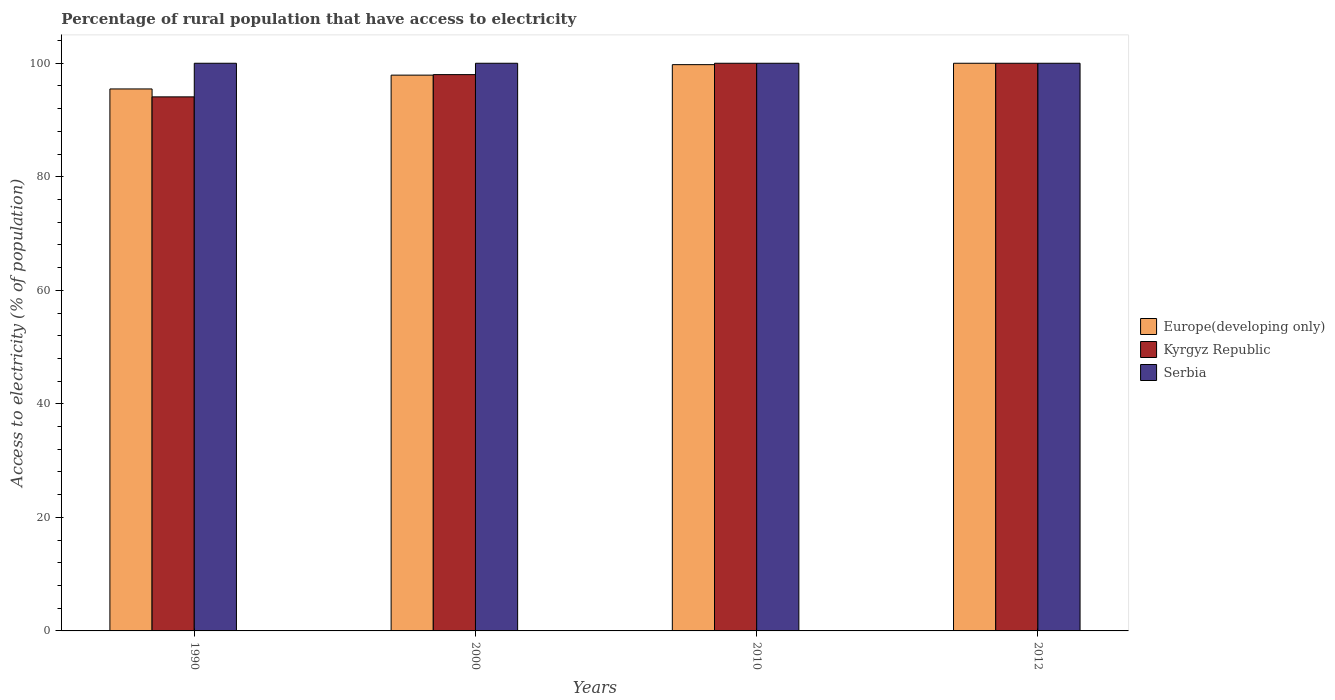How many different coloured bars are there?
Offer a terse response. 3. Are the number of bars on each tick of the X-axis equal?
Offer a terse response. Yes. How many bars are there on the 2nd tick from the left?
Provide a succinct answer. 3. How many bars are there on the 1st tick from the right?
Your response must be concise. 3. What is the label of the 1st group of bars from the left?
Ensure brevity in your answer.  1990. In how many cases, is the number of bars for a given year not equal to the number of legend labels?
Provide a short and direct response. 0. What is the percentage of rural population that have access to electricity in Kyrgyz Republic in 2000?
Provide a succinct answer. 98. Across all years, what is the minimum percentage of rural population that have access to electricity in Serbia?
Ensure brevity in your answer.  100. In which year was the percentage of rural population that have access to electricity in Kyrgyz Republic maximum?
Ensure brevity in your answer.  2010. What is the total percentage of rural population that have access to electricity in Serbia in the graph?
Your answer should be very brief. 400. What is the difference between the percentage of rural population that have access to electricity in Kyrgyz Republic in 1990 and that in 2012?
Provide a short and direct response. -5.92. What is the difference between the percentage of rural population that have access to electricity in Serbia in 2010 and the percentage of rural population that have access to electricity in Kyrgyz Republic in 2012?
Give a very brief answer. 0. What is the average percentage of rural population that have access to electricity in Kyrgyz Republic per year?
Offer a very short reply. 98.02. In the year 2012, what is the difference between the percentage of rural population that have access to electricity in Serbia and percentage of rural population that have access to electricity in Kyrgyz Republic?
Your answer should be very brief. 0. What is the ratio of the percentage of rural population that have access to electricity in Europe(developing only) in 1990 to that in 2010?
Your answer should be compact. 0.96. Is the percentage of rural population that have access to electricity in Europe(developing only) in 2010 less than that in 2012?
Give a very brief answer. Yes. What is the difference between the highest and the lowest percentage of rural population that have access to electricity in Europe(developing only)?
Your answer should be compact. 4.52. In how many years, is the percentage of rural population that have access to electricity in Serbia greater than the average percentage of rural population that have access to electricity in Serbia taken over all years?
Keep it short and to the point. 0. Is the sum of the percentage of rural population that have access to electricity in Kyrgyz Republic in 1990 and 2000 greater than the maximum percentage of rural population that have access to electricity in Europe(developing only) across all years?
Keep it short and to the point. Yes. What does the 1st bar from the left in 2012 represents?
Give a very brief answer. Europe(developing only). What does the 1st bar from the right in 1990 represents?
Your answer should be compact. Serbia. Is it the case that in every year, the sum of the percentage of rural population that have access to electricity in Serbia and percentage of rural population that have access to electricity in Europe(developing only) is greater than the percentage of rural population that have access to electricity in Kyrgyz Republic?
Provide a short and direct response. Yes. Are all the bars in the graph horizontal?
Your answer should be very brief. No. Does the graph contain any zero values?
Give a very brief answer. No. Does the graph contain grids?
Offer a terse response. No. Where does the legend appear in the graph?
Offer a terse response. Center right. How many legend labels are there?
Your response must be concise. 3. What is the title of the graph?
Make the answer very short. Percentage of rural population that have access to electricity. What is the label or title of the Y-axis?
Your response must be concise. Access to electricity (% of population). What is the Access to electricity (% of population) of Europe(developing only) in 1990?
Make the answer very short. 95.48. What is the Access to electricity (% of population) of Kyrgyz Republic in 1990?
Offer a very short reply. 94.08. What is the Access to electricity (% of population) in Serbia in 1990?
Make the answer very short. 100. What is the Access to electricity (% of population) of Europe(developing only) in 2000?
Offer a very short reply. 97.91. What is the Access to electricity (% of population) in Serbia in 2000?
Offer a very short reply. 100. What is the Access to electricity (% of population) of Europe(developing only) in 2010?
Your answer should be compact. 99.76. What is the Access to electricity (% of population) of Europe(developing only) in 2012?
Your response must be concise. 100. Across all years, what is the maximum Access to electricity (% of population) in Europe(developing only)?
Ensure brevity in your answer.  100. Across all years, what is the minimum Access to electricity (% of population) of Europe(developing only)?
Your answer should be very brief. 95.48. Across all years, what is the minimum Access to electricity (% of population) in Kyrgyz Republic?
Offer a very short reply. 94.08. What is the total Access to electricity (% of population) of Europe(developing only) in the graph?
Give a very brief answer. 393.14. What is the total Access to electricity (% of population) of Kyrgyz Republic in the graph?
Your answer should be compact. 392.08. What is the difference between the Access to electricity (% of population) in Europe(developing only) in 1990 and that in 2000?
Your answer should be compact. -2.43. What is the difference between the Access to electricity (% of population) in Kyrgyz Republic in 1990 and that in 2000?
Offer a very short reply. -3.92. What is the difference between the Access to electricity (% of population) of Serbia in 1990 and that in 2000?
Give a very brief answer. 0. What is the difference between the Access to electricity (% of population) of Europe(developing only) in 1990 and that in 2010?
Provide a short and direct response. -4.28. What is the difference between the Access to electricity (% of population) of Kyrgyz Republic in 1990 and that in 2010?
Keep it short and to the point. -5.92. What is the difference between the Access to electricity (% of population) in Serbia in 1990 and that in 2010?
Ensure brevity in your answer.  0. What is the difference between the Access to electricity (% of population) of Europe(developing only) in 1990 and that in 2012?
Offer a terse response. -4.52. What is the difference between the Access to electricity (% of population) in Kyrgyz Republic in 1990 and that in 2012?
Provide a succinct answer. -5.92. What is the difference between the Access to electricity (% of population) of Europe(developing only) in 2000 and that in 2010?
Make the answer very short. -1.85. What is the difference between the Access to electricity (% of population) of Kyrgyz Republic in 2000 and that in 2010?
Your answer should be compact. -2. What is the difference between the Access to electricity (% of population) of Serbia in 2000 and that in 2010?
Your response must be concise. 0. What is the difference between the Access to electricity (% of population) of Europe(developing only) in 2000 and that in 2012?
Give a very brief answer. -2.09. What is the difference between the Access to electricity (% of population) in Kyrgyz Republic in 2000 and that in 2012?
Make the answer very short. -2. What is the difference between the Access to electricity (% of population) of Serbia in 2000 and that in 2012?
Offer a terse response. 0. What is the difference between the Access to electricity (% of population) of Europe(developing only) in 2010 and that in 2012?
Make the answer very short. -0.24. What is the difference between the Access to electricity (% of population) in Kyrgyz Republic in 2010 and that in 2012?
Provide a short and direct response. 0. What is the difference between the Access to electricity (% of population) in Serbia in 2010 and that in 2012?
Offer a very short reply. 0. What is the difference between the Access to electricity (% of population) in Europe(developing only) in 1990 and the Access to electricity (% of population) in Kyrgyz Republic in 2000?
Keep it short and to the point. -2.52. What is the difference between the Access to electricity (% of population) in Europe(developing only) in 1990 and the Access to electricity (% of population) in Serbia in 2000?
Offer a terse response. -4.52. What is the difference between the Access to electricity (% of population) of Kyrgyz Republic in 1990 and the Access to electricity (% of population) of Serbia in 2000?
Your answer should be compact. -5.92. What is the difference between the Access to electricity (% of population) in Europe(developing only) in 1990 and the Access to electricity (% of population) in Kyrgyz Republic in 2010?
Provide a succinct answer. -4.52. What is the difference between the Access to electricity (% of population) in Europe(developing only) in 1990 and the Access to electricity (% of population) in Serbia in 2010?
Offer a very short reply. -4.52. What is the difference between the Access to electricity (% of population) in Kyrgyz Republic in 1990 and the Access to electricity (% of population) in Serbia in 2010?
Your answer should be very brief. -5.92. What is the difference between the Access to electricity (% of population) in Europe(developing only) in 1990 and the Access to electricity (% of population) in Kyrgyz Republic in 2012?
Make the answer very short. -4.52. What is the difference between the Access to electricity (% of population) of Europe(developing only) in 1990 and the Access to electricity (% of population) of Serbia in 2012?
Make the answer very short. -4.52. What is the difference between the Access to electricity (% of population) of Kyrgyz Republic in 1990 and the Access to electricity (% of population) of Serbia in 2012?
Give a very brief answer. -5.92. What is the difference between the Access to electricity (% of population) of Europe(developing only) in 2000 and the Access to electricity (% of population) of Kyrgyz Republic in 2010?
Offer a very short reply. -2.09. What is the difference between the Access to electricity (% of population) of Europe(developing only) in 2000 and the Access to electricity (% of population) of Serbia in 2010?
Offer a very short reply. -2.09. What is the difference between the Access to electricity (% of population) in Europe(developing only) in 2000 and the Access to electricity (% of population) in Kyrgyz Republic in 2012?
Offer a very short reply. -2.09. What is the difference between the Access to electricity (% of population) of Europe(developing only) in 2000 and the Access to electricity (% of population) of Serbia in 2012?
Provide a short and direct response. -2.09. What is the difference between the Access to electricity (% of population) in Kyrgyz Republic in 2000 and the Access to electricity (% of population) in Serbia in 2012?
Provide a succinct answer. -2. What is the difference between the Access to electricity (% of population) of Europe(developing only) in 2010 and the Access to electricity (% of population) of Kyrgyz Republic in 2012?
Your answer should be compact. -0.24. What is the difference between the Access to electricity (% of population) in Europe(developing only) in 2010 and the Access to electricity (% of population) in Serbia in 2012?
Your answer should be very brief. -0.24. What is the average Access to electricity (% of population) in Europe(developing only) per year?
Ensure brevity in your answer.  98.28. What is the average Access to electricity (% of population) in Kyrgyz Republic per year?
Ensure brevity in your answer.  98.02. In the year 1990, what is the difference between the Access to electricity (% of population) of Europe(developing only) and Access to electricity (% of population) of Kyrgyz Republic?
Make the answer very short. 1.4. In the year 1990, what is the difference between the Access to electricity (% of population) of Europe(developing only) and Access to electricity (% of population) of Serbia?
Your answer should be very brief. -4.52. In the year 1990, what is the difference between the Access to electricity (% of population) of Kyrgyz Republic and Access to electricity (% of population) of Serbia?
Provide a short and direct response. -5.92. In the year 2000, what is the difference between the Access to electricity (% of population) of Europe(developing only) and Access to electricity (% of population) of Kyrgyz Republic?
Your answer should be compact. -0.09. In the year 2000, what is the difference between the Access to electricity (% of population) in Europe(developing only) and Access to electricity (% of population) in Serbia?
Provide a succinct answer. -2.09. In the year 2010, what is the difference between the Access to electricity (% of population) of Europe(developing only) and Access to electricity (% of population) of Kyrgyz Republic?
Provide a succinct answer. -0.24. In the year 2010, what is the difference between the Access to electricity (% of population) of Europe(developing only) and Access to electricity (% of population) of Serbia?
Provide a short and direct response. -0.24. In the year 2010, what is the difference between the Access to electricity (% of population) of Kyrgyz Republic and Access to electricity (% of population) of Serbia?
Your answer should be compact. 0. In the year 2012, what is the difference between the Access to electricity (% of population) of Europe(developing only) and Access to electricity (% of population) of Kyrgyz Republic?
Keep it short and to the point. 0. What is the ratio of the Access to electricity (% of population) in Europe(developing only) in 1990 to that in 2000?
Provide a succinct answer. 0.98. What is the ratio of the Access to electricity (% of population) in Kyrgyz Republic in 1990 to that in 2000?
Offer a terse response. 0.96. What is the ratio of the Access to electricity (% of population) in Europe(developing only) in 1990 to that in 2010?
Offer a very short reply. 0.96. What is the ratio of the Access to electricity (% of population) in Kyrgyz Republic in 1990 to that in 2010?
Keep it short and to the point. 0.94. What is the ratio of the Access to electricity (% of population) in Europe(developing only) in 1990 to that in 2012?
Offer a very short reply. 0.95. What is the ratio of the Access to electricity (% of population) of Kyrgyz Republic in 1990 to that in 2012?
Offer a terse response. 0.94. What is the ratio of the Access to electricity (% of population) in Europe(developing only) in 2000 to that in 2010?
Your answer should be very brief. 0.98. What is the ratio of the Access to electricity (% of population) of Europe(developing only) in 2000 to that in 2012?
Offer a very short reply. 0.98. What is the ratio of the Access to electricity (% of population) of Kyrgyz Republic in 2010 to that in 2012?
Your answer should be compact. 1. What is the difference between the highest and the second highest Access to electricity (% of population) in Europe(developing only)?
Ensure brevity in your answer.  0.24. What is the difference between the highest and the second highest Access to electricity (% of population) of Kyrgyz Republic?
Your answer should be very brief. 0. What is the difference between the highest and the second highest Access to electricity (% of population) of Serbia?
Your response must be concise. 0. What is the difference between the highest and the lowest Access to electricity (% of population) in Europe(developing only)?
Make the answer very short. 4.52. What is the difference between the highest and the lowest Access to electricity (% of population) in Kyrgyz Republic?
Offer a very short reply. 5.92. What is the difference between the highest and the lowest Access to electricity (% of population) in Serbia?
Provide a short and direct response. 0. 